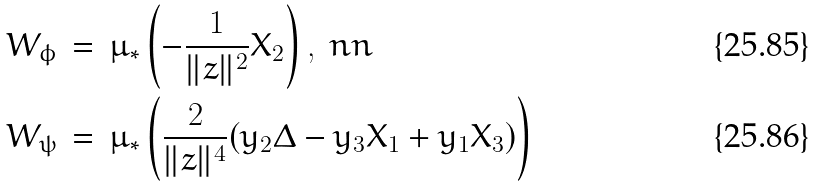Convert formula to latex. <formula><loc_0><loc_0><loc_500><loc_500>& W _ { \phi } \, = \, \mu _ { * } \left ( - \frac { 1 } { \| z \| ^ { 2 } } X _ { 2 } \right ) , \ n n \\ & W _ { \psi } \, = \, \mu _ { * } \left ( \frac { 2 } { \| z \| ^ { 4 } } ( y _ { 2 } \Delta - y _ { 3 } X _ { 1 } + y _ { 1 } X _ { 3 } ) \right )</formula> 